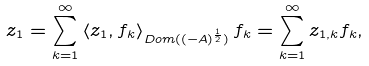Convert formula to latex. <formula><loc_0><loc_0><loc_500><loc_500>z _ { 1 } = \sum _ { k = 1 } ^ { \infty } \left \langle z _ { 1 } , f _ { k } \right \rangle _ { D o m ( ( - A ) ^ { \frac { 1 } { 2 } } ) } f _ { k } = \sum _ { k = 1 } ^ { \infty } z _ { 1 , k } f _ { k } ,</formula> 